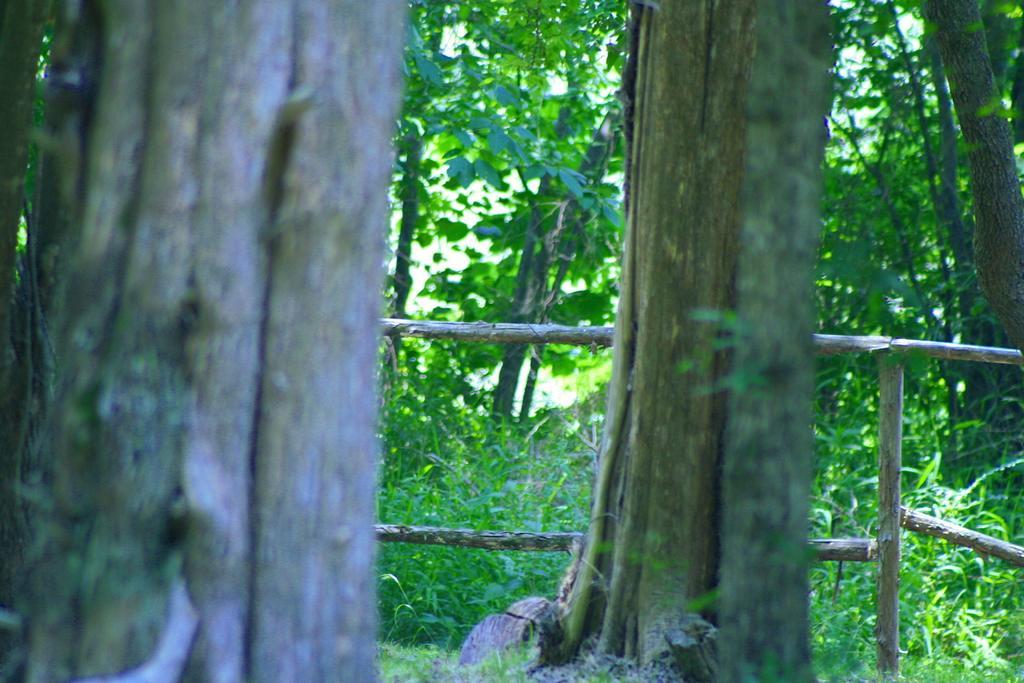In one or two sentences, can you explain what this image depicts? In this image there are trees and grass. 